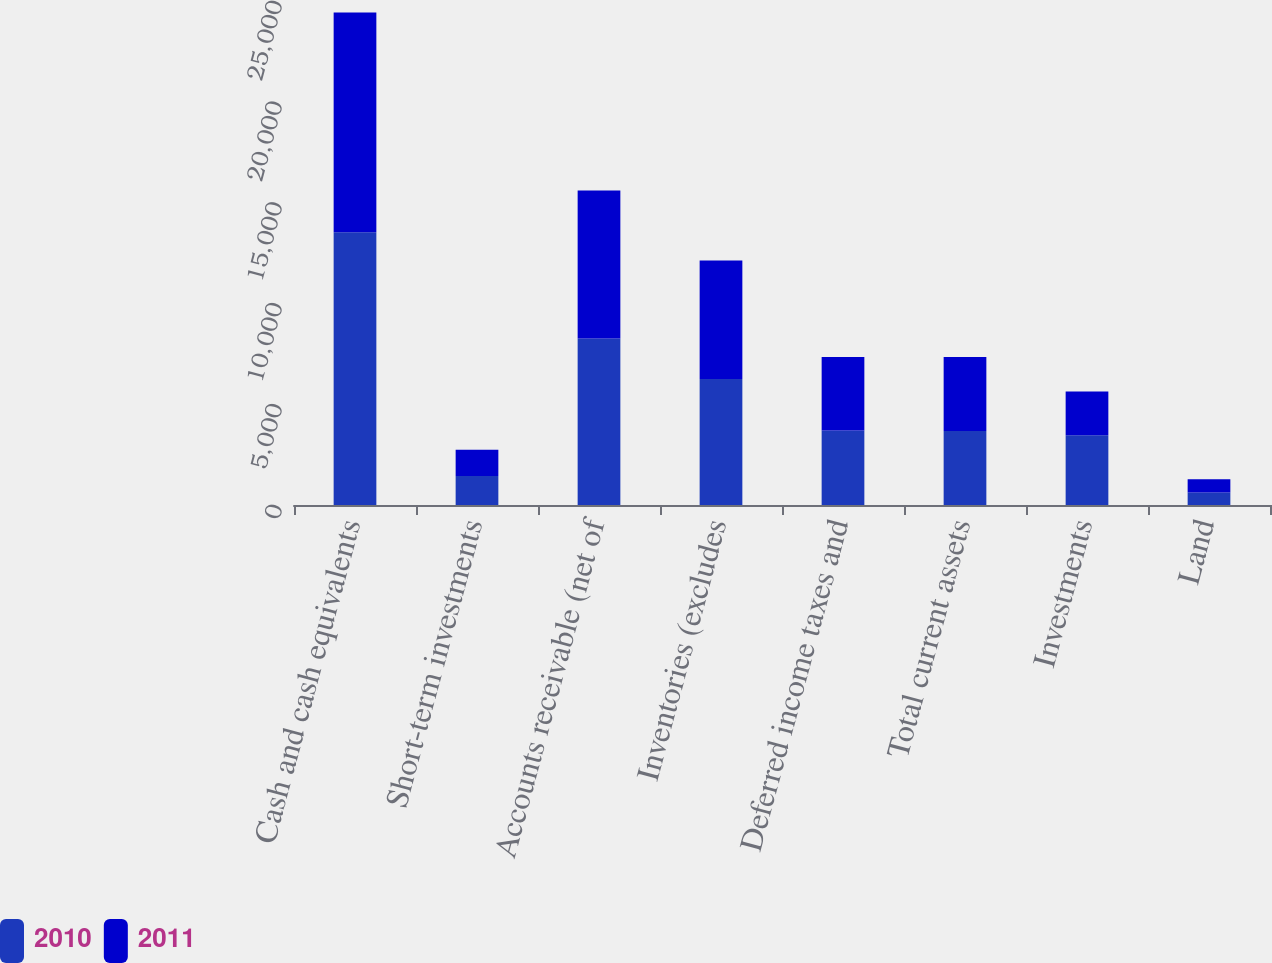Convert chart. <chart><loc_0><loc_0><loc_500><loc_500><stacked_bar_chart><ecel><fcel>Cash and cash equivalents<fcel>Short-term investments<fcel>Accounts receivable (net of<fcel>Inventories (excludes<fcel>Deferred income taxes and<fcel>Total current assets<fcel>Investments<fcel>Land<nl><fcel>2010<fcel>13531<fcel>1441<fcel>8261<fcel>6254<fcel>3694<fcel>3672.5<fcel>3458<fcel>623<nl><fcel>2011<fcel>10900<fcel>1301<fcel>7344<fcel>5868<fcel>3651<fcel>3672.5<fcel>2175<fcel>658<nl></chart> 